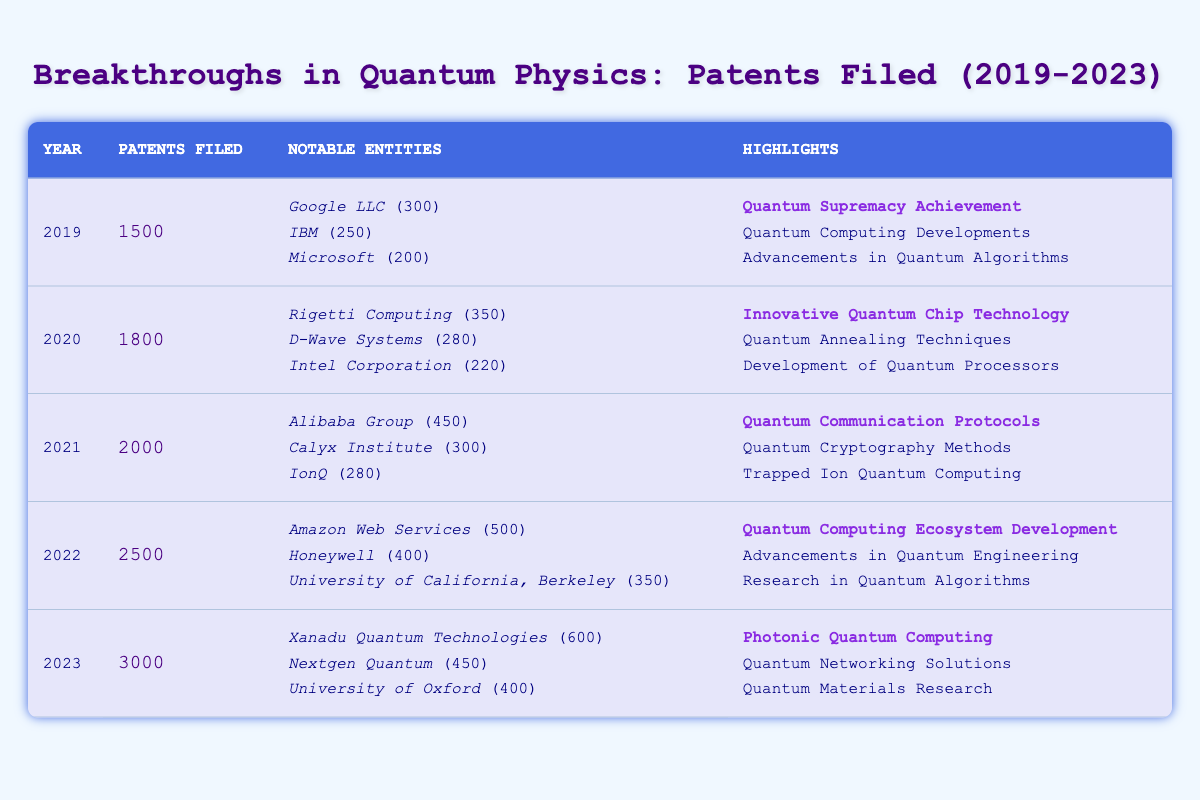What was the total number of patents filed in 2021? The table shows that in 2021, the number of patents filed was listed as 2000 in the "Patents Filed" column for that year.
Answer: 2000 Which entity filed the most patents in 2022? According to the table, Amazon Web Services filed the most patents in 2022 with 500 patents, as highlighted under "Notable Entities".
Answer: Amazon Web Services How many patents were filed in total from 2019 to 2023? To find the total, we add the patents filed each year: 1500 + 1800 + 2000 + 2500 + 3000 = 10800. So the total number of patents filed from 2019 to 2023 is 10800.
Answer: 10800 Did D-Wave Systems file more patents in 2020 than Microsoft did in 2019? In the table, D-Wave Systems filed 280 patents in 2020, while Microsoft filed 200 patents in 2019. Since 280 is greater than 200, the answer is yes.
Answer: Yes What was the percentage increase in patents filed from 2020 to 2021? The patents filed in 2020 were 1800, and in 2021 they were 2000. To calculate the percentage increase: (2000 - 1800) / 1800 × 100 = 11.11%.
Answer: 11.11% Which year had the least number of patents filed, and how many were there? Reviewing the table, 2019 had the least patents filed at 1500, as shown in the "Patents Filed" column.
Answer: 2019, 1500 What percentage of the total patents filed in 2022 were attributed to Amazon Web Services? Amazon Web Services filed 500 patents in 2022, and the total for that year was 2500. The percentage is calculated as (500 / 2500) × 100 = 20%.
Answer: 20% Which notable entity had the second-highest number of patents filed in 2019? In 2019, IBM filed 250 patents, which is the second-highest after Google LLC, who filed 300.
Answer: IBM What do the highlighted values in the table signify? The highlighted values indicate notable achievements associated with the patents filed by various entities, emphasizing their importance in the field of quantum physics.
Answer: Notable achievements How many patents did the University of California, Berkeley file in 2022? The table lists the University of California, Berkeley as having filed 350 patents in 2022.
Answer: 350 What was the average number of patents filed per year from 2019 to 2023? The total patents filed from 2019 to 2023 is 10800. Dividing this by the number of years (5): 10800 / 5 = 2160. Therefore, the average number of patents filed per year is 2160.
Answer: 2160 